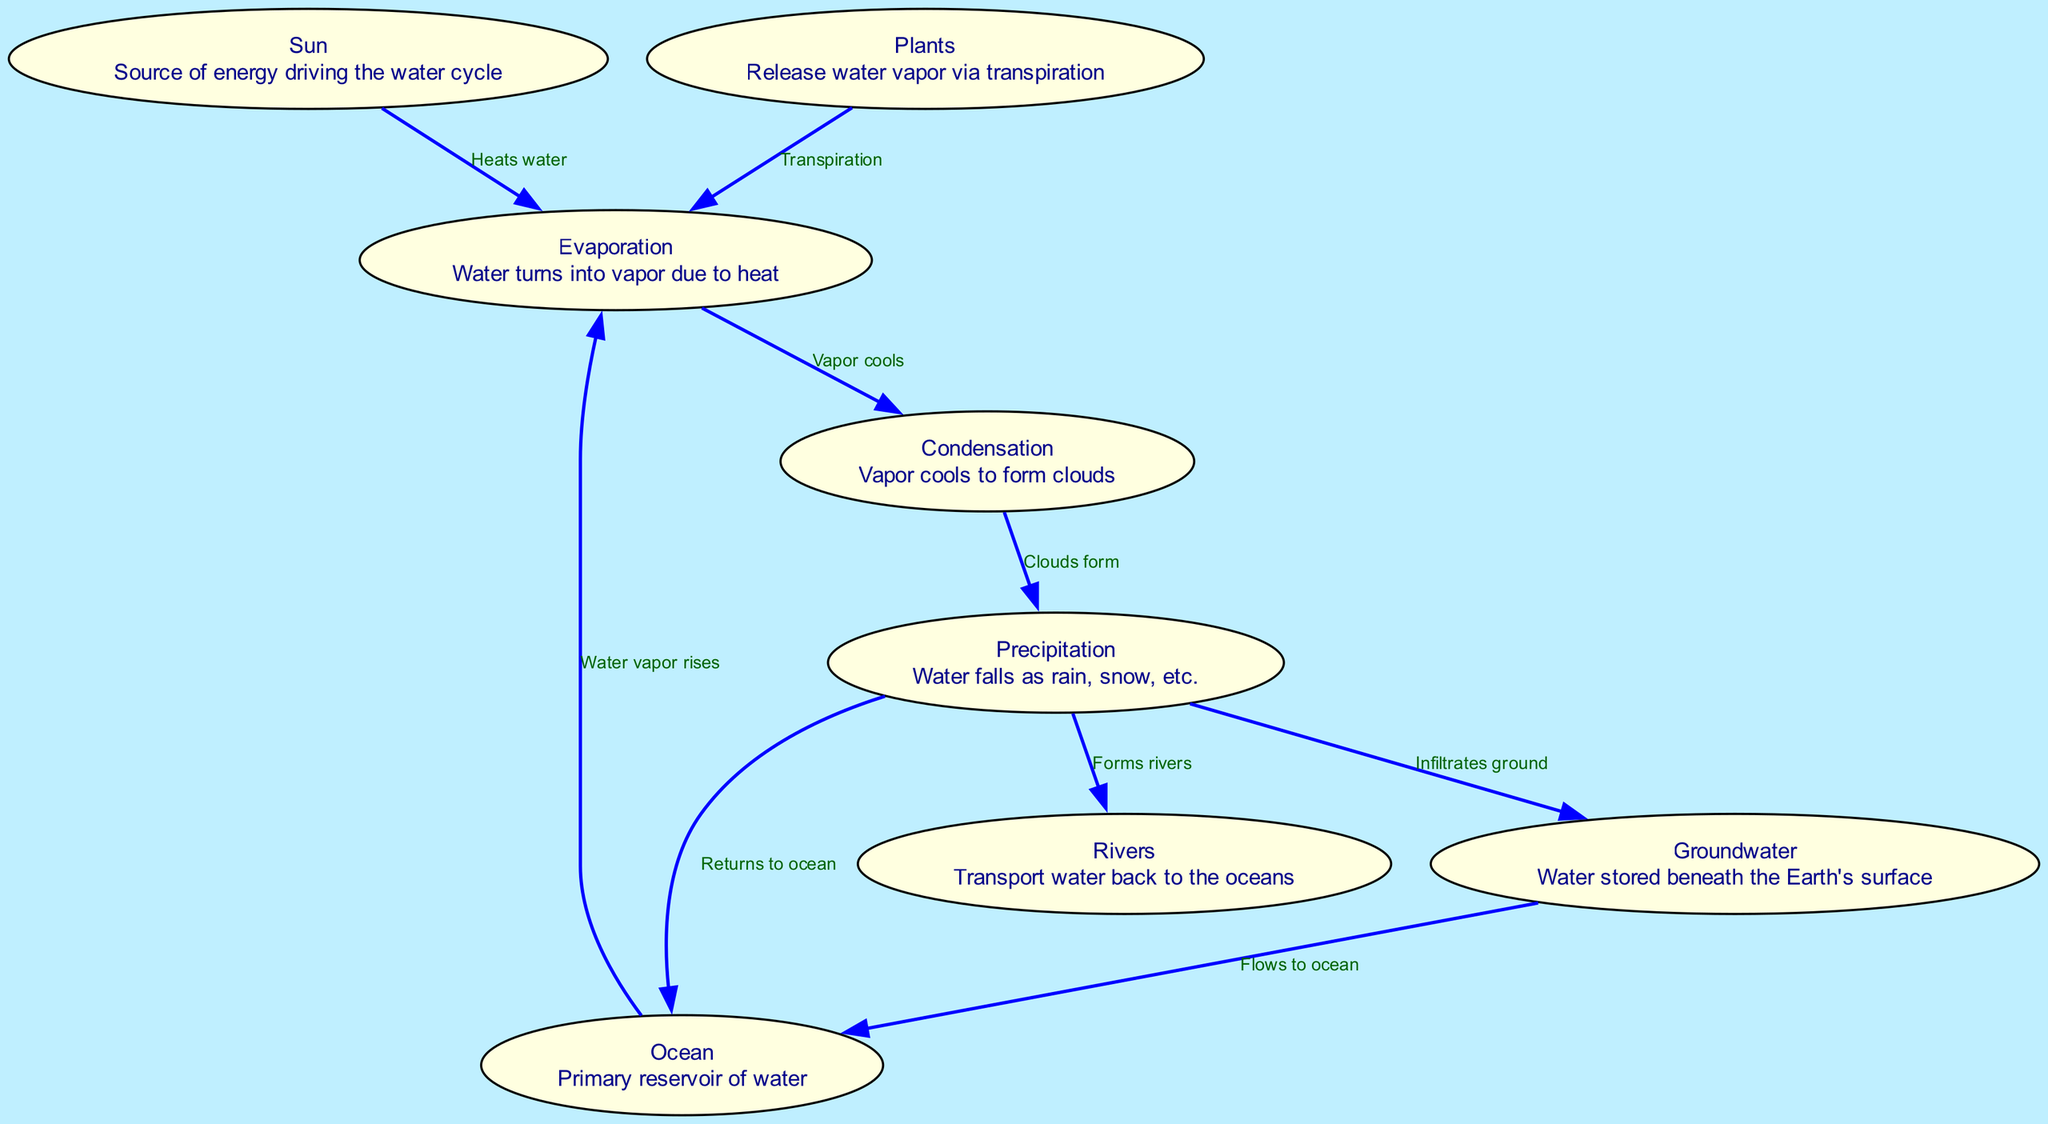What is the label of node 3? Node 3 in the diagram corresponds to the process of evaporation, which is described as "Water turns into vapor due to heat." Therefore, the label of node 3 is "Evaporation."
Answer: Evaporation How many nodes are present in the diagram? The diagram contains 8 distinct nodes that represent different elements of the water cycle. Counting each of these, we confirm there are 8 nodes total.
Answer: 8 What happens during the process represented by node 4? Node 4 represents condensation, where water vapor cools and forms clouds. This process is essential for cloud formation in the water cycle.
Answer: Clouds form Which node describes the role of the sun in the water cycle? The sun is described in node 1, which indicates that it is the source of energy driving the water cycle. This highlights the sun's important role in initiating evaporation.
Answer: Sun How does water return to the ocean according to the diagram? Water returns to the ocean through precipitation, as shown from node 5 (precipitation) to node 2 (ocean). Precipitation is the means through which water falls back to the primary reservoir.
Answer: Returns to ocean What two processes allow water to move from the ground to the ocean? The two processes that allow water to move from the ground back to the ocean are infiltration (from precipitation to groundwater) and river flow (from rivers to the ocean). This represents the cyclical nature of water movement.
Answer: Flows to ocean, Forms rivers Which node specifically mentions plants? Node 8 mentions plants, specifically describing that they release water vapor via the process of transpiration. This underscores the role of plants in the hydrological cycle.
Answer: Plants What is the relationship between evaporation and transpiration? Evaporation and transpiration are connected processes; transpiration involves plants releasing water vapor, which is part of the broader evaporation stage. Together they contribute to the moisture in the air, indicating a relationship where both processes lead to water vapor being present in the atmosphere.
Answer: Transpiration How many edges are there in the diagram? The diagram features 8 edges, which represent the relationships and flows between the various nodes, showing how each component of the water cycle interacts with others. Counting them gives a total of 8 edges.
Answer: 8 